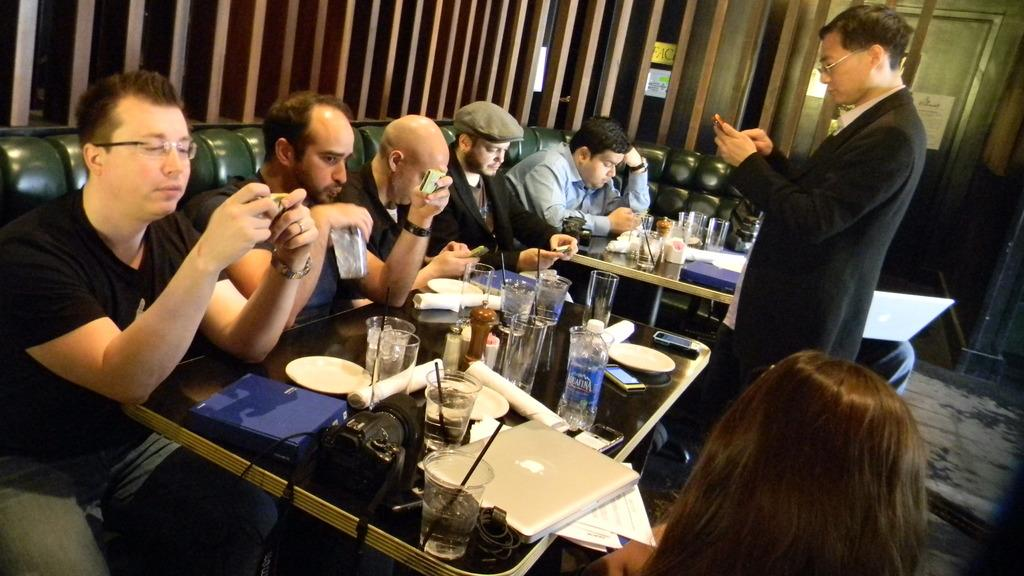Where was the image taken? The image was taken inside a room. What type of furniture is present in the room? There are sofas and tables in the room. What items can be seen on the table in the image? There are glasses, laptops, papers, phones, tissues, and cameras on the table. How many clocks are visible on the sofas in the image? There are no clocks visible on the sofas in the image. What type of footwear is being worn by the people in the image? There are no people visible in the image, so it is impossible to determine what type of footwear they might be wearing. 